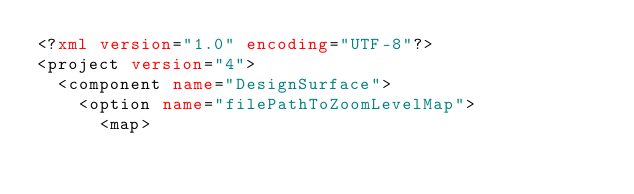<code> <loc_0><loc_0><loc_500><loc_500><_XML_><?xml version="1.0" encoding="UTF-8"?>
<project version="4">
  <component name="DesignSurface">
    <option name="filePathToZoomLevelMap">
      <map></code> 